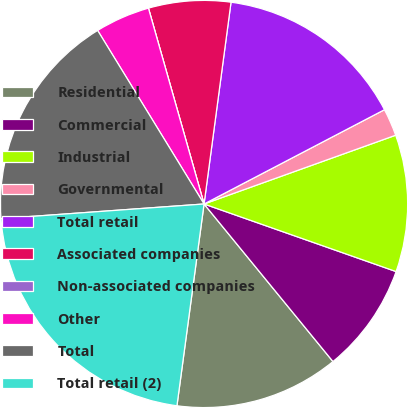Convert chart. <chart><loc_0><loc_0><loc_500><loc_500><pie_chart><fcel>Residential<fcel>Commercial<fcel>Industrial<fcel>Governmental<fcel>Total retail<fcel>Associated companies<fcel>Non-associated companies<fcel>Other<fcel>Total<fcel>Total retail (2)<nl><fcel>13.04%<fcel>8.7%<fcel>10.87%<fcel>2.18%<fcel>15.22%<fcel>6.52%<fcel>0.0%<fcel>4.35%<fcel>17.39%<fcel>21.73%<nl></chart> 